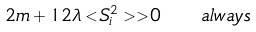<formula> <loc_0><loc_0><loc_500><loc_500>2 m + 1 2 \lambda < S _ { i } ^ { 2 } > \, > 0 \quad a l w a y s</formula> 